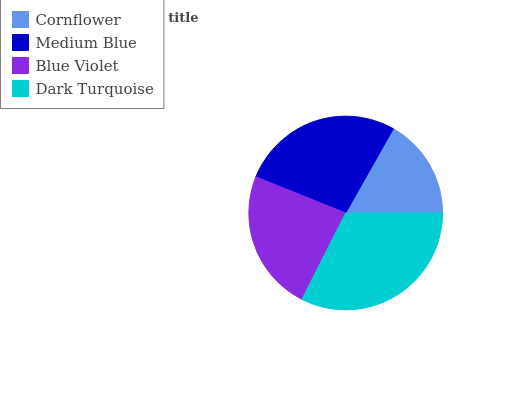Is Cornflower the minimum?
Answer yes or no. Yes. Is Dark Turquoise the maximum?
Answer yes or no. Yes. Is Medium Blue the minimum?
Answer yes or no. No. Is Medium Blue the maximum?
Answer yes or no. No. Is Medium Blue greater than Cornflower?
Answer yes or no. Yes. Is Cornflower less than Medium Blue?
Answer yes or no. Yes. Is Cornflower greater than Medium Blue?
Answer yes or no. No. Is Medium Blue less than Cornflower?
Answer yes or no. No. Is Medium Blue the high median?
Answer yes or no. Yes. Is Blue Violet the low median?
Answer yes or no. Yes. Is Dark Turquoise the high median?
Answer yes or no. No. Is Dark Turquoise the low median?
Answer yes or no. No. 